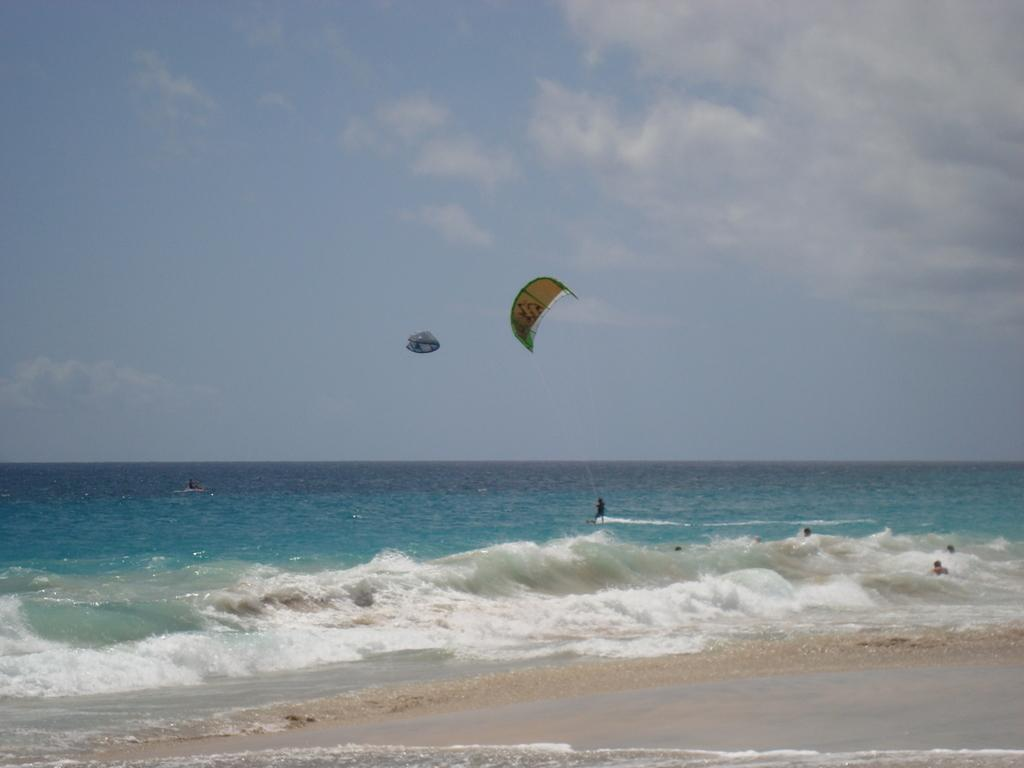What is located in the middle of the image? There is water in the middle of the image. What activity are the people doing on the water? The people are doing parasailing on the water. What can be seen in the top of the image? There are clouds visible in the top of the image, and the sky is also visible. What type of spacecraft can be seen in the image? There is no spacecraft present in the image; it features water and people parasailing. How many toes are visible on the people parasailing in the image? The image does not show the toes of the people parasailing, so it cannot be determined from the image. 